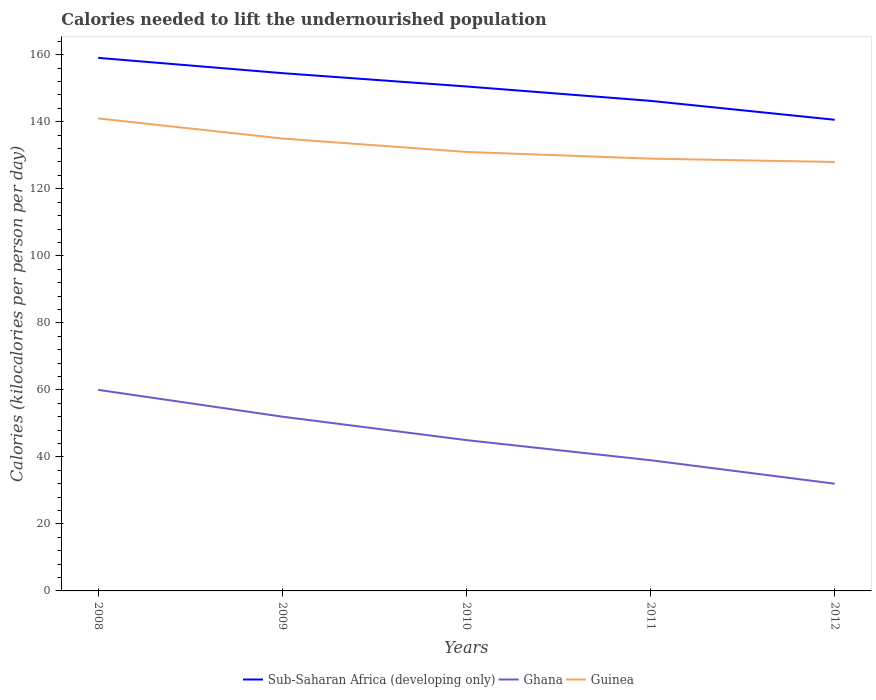How many different coloured lines are there?
Provide a succinct answer. 3. Is the number of lines equal to the number of legend labels?
Provide a succinct answer. Yes. Across all years, what is the maximum total calories needed to lift the undernourished population in Guinea?
Provide a succinct answer. 128. In which year was the total calories needed to lift the undernourished population in Ghana maximum?
Provide a succinct answer. 2012. What is the total total calories needed to lift the undernourished population in Ghana in the graph?
Your response must be concise. 20. What is the difference between the highest and the second highest total calories needed to lift the undernourished population in Ghana?
Your response must be concise. 28. What is the difference between the highest and the lowest total calories needed to lift the undernourished population in Guinea?
Provide a short and direct response. 2. How many years are there in the graph?
Offer a very short reply. 5. What is the difference between two consecutive major ticks on the Y-axis?
Offer a very short reply. 20. Are the values on the major ticks of Y-axis written in scientific E-notation?
Offer a terse response. No. Does the graph contain any zero values?
Give a very brief answer. No. What is the title of the graph?
Your answer should be very brief. Calories needed to lift the undernourished population. Does "Niger" appear as one of the legend labels in the graph?
Provide a succinct answer. No. What is the label or title of the X-axis?
Your answer should be compact. Years. What is the label or title of the Y-axis?
Your response must be concise. Calories (kilocalories per person per day). What is the Calories (kilocalories per person per day) in Sub-Saharan Africa (developing only) in 2008?
Offer a very short reply. 159.07. What is the Calories (kilocalories per person per day) in Guinea in 2008?
Provide a short and direct response. 141. What is the Calories (kilocalories per person per day) of Sub-Saharan Africa (developing only) in 2009?
Give a very brief answer. 154.51. What is the Calories (kilocalories per person per day) of Guinea in 2009?
Your response must be concise. 135. What is the Calories (kilocalories per person per day) in Sub-Saharan Africa (developing only) in 2010?
Offer a terse response. 150.54. What is the Calories (kilocalories per person per day) of Guinea in 2010?
Give a very brief answer. 131. What is the Calories (kilocalories per person per day) in Sub-Saharan Africa (developing only) in 2011?
Your response must be concise. 146.24. What is the Calories (kilocalories per person per day) of Ghana in 2011?
Provide a short and direct response. 39. What is the Calories (kilocalories per person per day) of Guinea in 2011?
Provide a short and direct response. 129. What is the Calories (kilocalories per person per day) of Sub-Saharan Africa (developing only) in 2012?
Make the answer very short. 140.6. What is the Calories (kilocalories per person per day) in Guinea in 2012?
Provide a succinct answer. 128. Across all years, what is the maximum Calories (kilocalories per person per day) of Sub-Saharan Africa (developing only)?
Keep it short and to the point. 159.07. Across all years, what is the maximum Calories (kilocalories per person per day) of Ghana?
Your answer should be compact. 60. Across all years, what is the maximum Calories (kilocalories per person per day) of Guinea?
Offer a very short reply. 141. Across all years, what is the minimum Calories (kilocalories per person per day) of Sub-Saharan Africa (developing only)?
Ensure brevity in your answer.  140.6. Across all years, what is the minimum Calories (kilocalories per person per day) in Guinea?
Ensure brevity in your answer.  128. What is the total Calories (kilocalories per person per day) of Sub-Saharan Africa (developing only) in the graph?
Make the answer very short. 750.96. What is the total Calories (kilocalories per person per day) in Ghana in the graph?
Make the answer very short. 228. What is the total Calories (kilocalories per person per day) in Guinea in the graph?
Offer a terse response. 664. What is the difference between the Calories (kilocalories per person per day) of Sub-Saharan Africa (developing only) in 2008 and that in 2009?
Your answer should be compact. 4.56. What is the difference between the Calories (kilocalories per person per day) of Sub-Saharan Africa (developing only) in 2008 and that in 2010?
Make the answer very short. 8.54. What is the difference between the Calories (kilocalories per person per day) in Ghana in 2008 and that in 2010?
Your answer should be very brief. 15. What is the difference between the Calories (kilocalories per person per day) in Guinea in 2008 and that in 2010?
Keep it short and to the point. 10. What is the difference between the Calories (kilocalories per person per day) in Sub-Saharan Africa (developing only) in 2008 and that in 2011?
Your answer should be compact. 12.83. What is the difference between the Calories (kilocalories per person per day) of Sub-Saharan Africa (developing only) in 2008 and that in 2012?
Provide a short and direct response. 18.47. What is the difference between the Calories (kilocalories per person per day) in Ghana in 2008 and that in 2012?
Ensure brevity in your answer.  28. What is the difference between the Calories (kilocalories per person per day) in Guinea in 2008 and that in 2012?
Ensure brevity in your answer.  13. What is the difference between the Calories (kilocalories per person per day) of Sub-Saharan Africa (developing only) in 2009 and that in 2010?
Provide a succinct answer. 3.97. What is the difference between the Calories (kilocalories per person per day) in Guinea in 2009 and that in 2010?
Provide a short and direct response. 4. What is the difference between the Calories (kilocalories per person per day) of Sub-Saharan Africa (developing only) in 2009 and that in 2011?
Your response must be concise. 8.27. What is the difference between the Calories (kilocalories per person per day) of Sub-Saharan Africa (developing only) in 2009 and that in 2012?
Your answer should be compact. 13.91. What is the difference between the Calories (kilocalories per person per day) of Sub-Saharan Africa (developing only) in 2010 and that in 2011?
Provide a short and direct response. 4.3. What is the difference between the Calories (kilocalories per person per day) of Sub-Saharan Africa (developing only) in 2010 and that in 2012?
Offer a very short reply. 9.93. What is the difference between the Calories (kilocalories per person per day) in Ghana in 2010 and that in 2012?
Give a very brief answer. 13. What is the difference between the Calories (kilocalories per person per day) in Guinea in 2010 and that in 2012?
Your response must be concise. 3. What is the difference between the Calories (kilocalories per person per day) in Sub-Saharan Africa (developing only) in 2011 and that in 2012?
Make the answer very short. 5.64. What is the difference between the Calories (kilocalories per person per day) in Guinea in 2011 and that in 2012?
Your answer should be very brief. 1. What is the difference between the Calories (kilocalories per person per day) of Sub-Saharan Africa (developing only) in 2008 and the Calories (kilocalories per person per day) of Ghana in 2009?
Ensure brevity in your answer.  107.07. What is the difference between the Calories (kilocalories per person per day) of Sub-Saharan Africa (developing only) in 2008 and the Calories (kilocalories per person per day) of Guinea in 2009?
Your answer should be very brief. 24.07. What is the difference between the Calories (kilocalories per person per day) of Ghana in 2008 and the Calories (kilocalories per person per day) of Guinea in 2009?
Offer a terse response. -75. What is the difference between the Calories (kilocalories per person per day) in Sub-Saharan Africa (developing only) in 2008 and the Calories (kilocalories per person per day) in Ghana in 2010?
Offer a terse response. 114.07. What is the difference between the Calories (kilocalories per person per day) in Sub-Saharan Africa (developing only) in 2008 and the Calories (kilocalories per person per day) in Guinea in 2010?
Ensure brevity in your answer.  28.07. What is the difference between the Calories (kilocalories per person per day) in Ghana in 2008 and the Calories (kilocalories per person per day) in Guinea in 2010?
Provide a short and direct response. -71. What is the difference between the Calories (kilocalories per person per day) of Sub-Saharan Africa (developing only) in 2008 and the Calories (kilocalories per person per day) of Ghana in 2011?
Provide a succinct answer. 120.07. What is the difference between the Calories (kilocalories per person per day) of Sub-Saharan Africa (developing only) in 2008 and the Calories (kilocalories per person per day) of Guinea in 2011?
Offer a very short reply. 30.07. What is the difference between the Calories (kilocalories per person per day) of Ghana in 2008 and the Calories (kilocalories per person per day) of Guinea in 2011?
Your response must be concise. -69. What is the difference between the Calories (kilocalories per person per day) in Sub-Saharan Africa (developing only) in 2008 and the Calories (kilocalories per person per day) in Ghana in 2012?
Give a very brief answer. 127.07. What is the difference between the Calories (kilocalories per person per day) of Sub-Saharan Africa (developing only) in 2008 and the Calories (kilocalories per person per day) of Guinea in 2012?
Offer a very short reply. 31.07. What is the difference between the Calories (kilocalories per person per day) in Ghana in 2008 and the Calories (kilocalories per person per day) in Guinea in 2012?
Offer a terse response. -68. What is the difference between the Calories (kilocalories per person per day) in Sub-Saharan Africa (developing only) in 2009 and the Calories (kilocalories per person per day) in Ghana in 2010?
Offer a terse response. 109.51. What is the difference between the Calories (kilocalories per person per day) of Sub-Saharan Africa (developing only) in 2009 and the Calories (kilocalories per person per day) of Guinea in 2010?
Offer a terse response. 23.51. What is the difference between the Calories (kilocalories per person per day) in Ghana in 2009 and the Calories (kilocalories per person per day) in Guinea in 2010?
Keep it short and to the point. -79. What is the difference between the Calories (kilocalories per person per day) in Sub-Saharan Africa (developing only) in 2009 and the Calories (kilocalories per person per day) in Ghana in 2011?
Ensure brevity in your answer.  115.51. What is the difference between the Calories (kilocalories per person per day) in Sub-Saharan Africa (developing only) in 2009 and the Calories (kilocalories per person per day) in Guinea in 2011?
Your answer should be compact. 25.51. What is the difference between the Calories (kilocalories per person per day) of Ghana in 2009 and the Calories (kilocalories per person per day) of Guinea in 2011?
Ensure brevity in your answer.  -77. What is the difference between the Calories (kilocalories per person per day) in Sub-Saharan Africa (developing only) in 2009 and the Calories (kilocalories per person per day) in Ghana in 2012?
Offer a very short reply. 122.51. What is the difference between the Calories (kilocalories per person per day) of Sub-Saharan Africa (developing only) in 2009 and the Calories (kilocalories per person per day) of Guinea in 2012?
Your answer should be compact. 26.51. What is the difference between the Calories (kilocalories per person per day) of Ghana in 2009 and the Calories (kilocalories per person per day) of Guinea in 2012?
Offer a terse response. -76. What is the difference between the Calories (kilocalories per person per day) of Sub-Saharan Africa (developing only) in 2010 and the Calories (kilocalories per person per day) of Ghana in 2011?
Your answer should be compact. 111.54. What is the difference between the Calories (kilocalories per person per day) of Sub-Saharan Africa (developing only) in 2010 and the Calories (kilocalories per person per day) of Guinea in 2011?
Keep it short and to the point. 21.54. What is the difference between the Calories (kilocalories per person per day) of Ghana in 2010 and the Calories (kilocalories per person per day) of Guinea in 2011?
Make the answer very short. -84. What is the difference between the Calories (kilocalories per person per day) of Sub-Saharan Africa (developing only) in 2010 and the Calories (kilocalories per person per day) of Ghana in 2012?
Your answer should be very brief. 118.54. What is the difference between the Calories (kilocalories per person per day) in Sub-Saharan Africa (developing only) in 2010 and the Calories (kilocalories per person per day) in Guinea in 2012?
Keep it short and to the point. 22.54. What is the difference between the Calories (kilocalories per person per day) of Ghana in 2010 and the Calories (kilocalories per person per day) of Guinea in 2012?
Your answer should be very brief. -83. What is the difference between the Calories (kilocalories per person per day) in Sub-Saharan Africa (developing only) in 2011 and the Calories (kilocalories per person per day) in Ghana in 2012?
Your answer should be very brief. 114.24. What is the difference between the Calories (kilocalories per person per day) in Sub-Saharan Africa (developing only) in 2011 and the Calories (kilocalories per person per day) in Guinea in 2012?
Offer a terse response. 18.24. What is the difference between the Calories (kilocalories per person per day) in Ghana in 2011 and the Calories (kilocalories per person per day) in Guinea in 2012?
Offer a terse response. -89. What is the average Calories (kilocalories per person per day) of Sub-Saharan Africa (developing only) per year?
Offer a terse response. 150.19. What is the average Calories (kilocalories per person per day) in Ghana per year?
Provide a short and direct response. 45.6. What is the average Calories (kilocalories per person per day) in Guinea per year?
Provide a short and direct response. 132.8. In the year 2008, what is the difference between the Calories (kilocalories per person per day) in Sub-Saharan Africa (developing only) and Calories (kilocalories per person per day) in Ghana?
Offer a terse response. 99.07. In the year 2008, what is the difference between the Calories (kilocalories per person per day) of Sub-Saharan Africa (developing only) and Calories (kilocalories per person per day) of Guinea?
Offer a terse response. 18.07. In the year 2008, what is the difference between the Calories (kilocalories per person per day) of Ghana and Calories (kilocalories per person per day) of Guinea?
Provide a succinct answer. -81. In the year 2009, what is the difference between the Calories (kilocalories per person per day) of Sub-Saharan Africa (developing only) and Calories (kilocalories per person per day) of Ghana?
Your answer should be compact. 102.51. In the year 2009, what is the difference between the Calories (kilocalories per person per day) in Sub-Saharan Africa (developing only) and Calories (kilocalories per person per day) in Guinea?
Provide a short and direct response. 19.51. In the year 2009, what is the difference between the Calories (kilocalories per person per day) in Ghana and Calories (kilocalories per person per day) in Guinea?
Make the answer very short. -83. In the year 2010, what is the difference between the Calories (kilocalories per person per day) of Sub-Saharan Africa (developing only) and Calories (kilocalories per person per day) of Ghana?
Keep it short and to the point. 105.54. In the year 2010, what is the difference between the Calories (kilocalories per person per day) of Sub-Saharan Africa (developing only) and Calories (kilocalories per person per day) of Guinea?
Make the answer very short. 19.54. In the year 2010, what is the difference between the Calories (kilocalories per person per day) in Ghana and Calories (kilocalories per person per day) in Guinea?
Give a very brief answer. -86. In the year 2011, what is the difference between the Calories (kilocalories per person per day) of Sub-Saharan Africa (developing only) and Calories (kilocalories per person per day) of Ghana?
Your answer should be very brief. 107.24. In the year 2011, what is the difference between the Calories (kilocalories per person per day) in Sub-Saharan Africa (developing only) and Calories (kilocalories per person per day) in Guinea?
Your answer should be very brief. 17.24. In the year 2011, what is the difference between the Calories (kilocalories per person per day) of Ghana and Calories (kilocalories per person per day) of Guinea?
Make the answer very short. -90. In the year 2012, what is the difference between the Calories (kilocalories per person per day) in Sub-Saharan Africa (developing only) and Calories (kilocalories per person per day) in Ghana?
Keep it short and to the point. 108.6. In the year 2012, what is the difference between the Calories (kilocalories per person per day) of Sub-Saharan Africa (developing only) and Calories (kilocalories per person per day) of Guinea?
Your response must be concise. 12.6. In the year 2012, what is the difference between the Calories (kilocalories per person per day) of Ghana and Calories (kilocalories per person per day) of Guinea?
Your response must be concise. -96. What is the ratio of the Calories (kilocalories per person per day) in Sub-Saharan Africa (developing only) in 2008 to that in 2009?
Your response must be concise. 1.03. What is the ratio of the Calories (kilocalories per person per day) in Ghana in 2008 to that in 2009?
Your answer should be very brief. 1.15. What is the ratio of the Calories (kilocalories per person per day) of Guinea in 2008 to that in 2009?
Provide a short and direct response. 1.04. What is the ratio of the Calories (kilocalories per person per day) in Sub-Saharan Africa (developing only) in 2008 to that in 2010?
Provide a short and direct response. 1.06. What is the ratio of the Calories (kilocalories per person per day) in Guinea in 2008 to that in 2010?
Your answer should be very brief. 1.08. What is the ratio of the Calories (kilocalories per person per day) in Sub-Saharan Africa (developing only) in 2008 to that in 2011?
Your answer should be very brief. 1.09. What is the ratio of the Calories (kilocalories per person per day) in Ghana in 2008 to that in 2011?
Offer a terse response. 1.54. What is the ratio of the Calories (kilocalories per person per day) in Guinea in 2008 to that in 2011?
Provide a short and direct response. 1.09. What is the ratio of the Calories (kilocalories per person per day) of Sub-Saharan Africa (developing only) in 2008 to that in 2012?
Offer a terse response. 1.13. What is the ratio of the Calories (kilocalories per person per day) in Ghana in 2008 to that in 2012?
Make the answer very short. 1.88. What is the ratio of the Calories (kilocalories per person per day) of Guinea in 2008 to that in 2012?
Your answer should be compact. 1.1. What is the ratio of the Calories (kilocalories per person per day) in Sub-Saharan Africa (developing only) in 2009 to that in 2010?
Keep it short and to the point. 1.03. What is the ratio of the Calories (kilocalories per person per day) of Ghana in 2009 to that in 2010?
Offer a very short reply. 1.16. What is the ratio of the Calories (kilocalories per person per day) in Guinea in 2009 to that in 2010?
Provide a succinct answer. 1.03. What is the ratio of the Calories (kilocalories per person per day) in Sub-Saharan Africa (developing only) in 2009 to that in 2011?
Your answer should be very brief. 1.06. What is the ratio of the Calories (kilocalories per person per day) of Guinea in 2009 to that in 2011?
Your answer should be very brief. 1.05. What is the ratio of the Calories (kilocalories per person per day) of Sub-Saharan Africa (developing only) in 2009 to that in 2012?
Provide a short and direct response. 1.1. What is the ratio of the Calories (kilocalories per person per day) in Ghana in 2009 to that in 2012?
Keep it short and to the point. 1.62. What is the ratio of the Calories (kilocalories per person per day) in Guinea in 2009 to that in 2012?
Your response must be concise. 1.05. What is the ratio of the Calories (kilocalories per person per day) in Sub-Saharan Africa (developing only) in 2010 to that in 2011?
Your response must be concise. 1.03. What is the ratio of the Calories (kilocalories per person per day) of Ghana in 2010 to that in 2011?
Your answer should be very brief. 1.15. What is the ratio of the Calories (kilocalories per person per day) in Guinea in 2010 to that in 2011?
Your response must be concise. 1.02. What is the ratio of the Calories (kilocalories per person per day) of Sub-Saharan Africa (developing only) in 2010 to that in 2012?
Your answer should be very brief. 1.07. What is the ratio of the Calories (kilocalories per person per day) in Ghana in 2010 to that in 2012?
Your answer should be very brief. 1.41. What is the ratio of the Calories (kilocalories per person per day) of Guinea in 2010 to that in 2012?
Offer a very short reply. 1.02. What is the ratio of the Calories (kilocalories per person per day) in Sub-Saharan Africa (developing only) in 2011 to that in 2012?
Provide a succinct answer. 1.04. What is the ratio of the Calories (kilocalories per person per day) in Ghana in 2011 to that in 2012?
Offer a very short reply. 1.22. What is the ratio of the Calories (kilocalories per person per day) in Guinea in 2011 to that in 2012?
Give a very brief answer. 1.01. What is the difference between the highest and the second highest Calories (kilocalories per person per day) in Sub-Saharan Africa (developing only)?
Make the answer very short. 4.56. What is the difference between the highest and the second highest Calories (kilocalories per person per day) in Ghana?
Provide a succinct answer. 8. What is the difference between the highest and the lowest Calories (kilocalories per person per day) of Sub-Saharan Africa (developing only)?
Keep it short and to the point. 18.47. What is the difference between the highest and the lowest Calories (kilocalories per person per day) in Ghana?
Your answer should be very brief. 28. What is the difference between the highest and the lowest Calories (kilocalories per person per day) of Guinea?
Your answer should be compact. 13. 